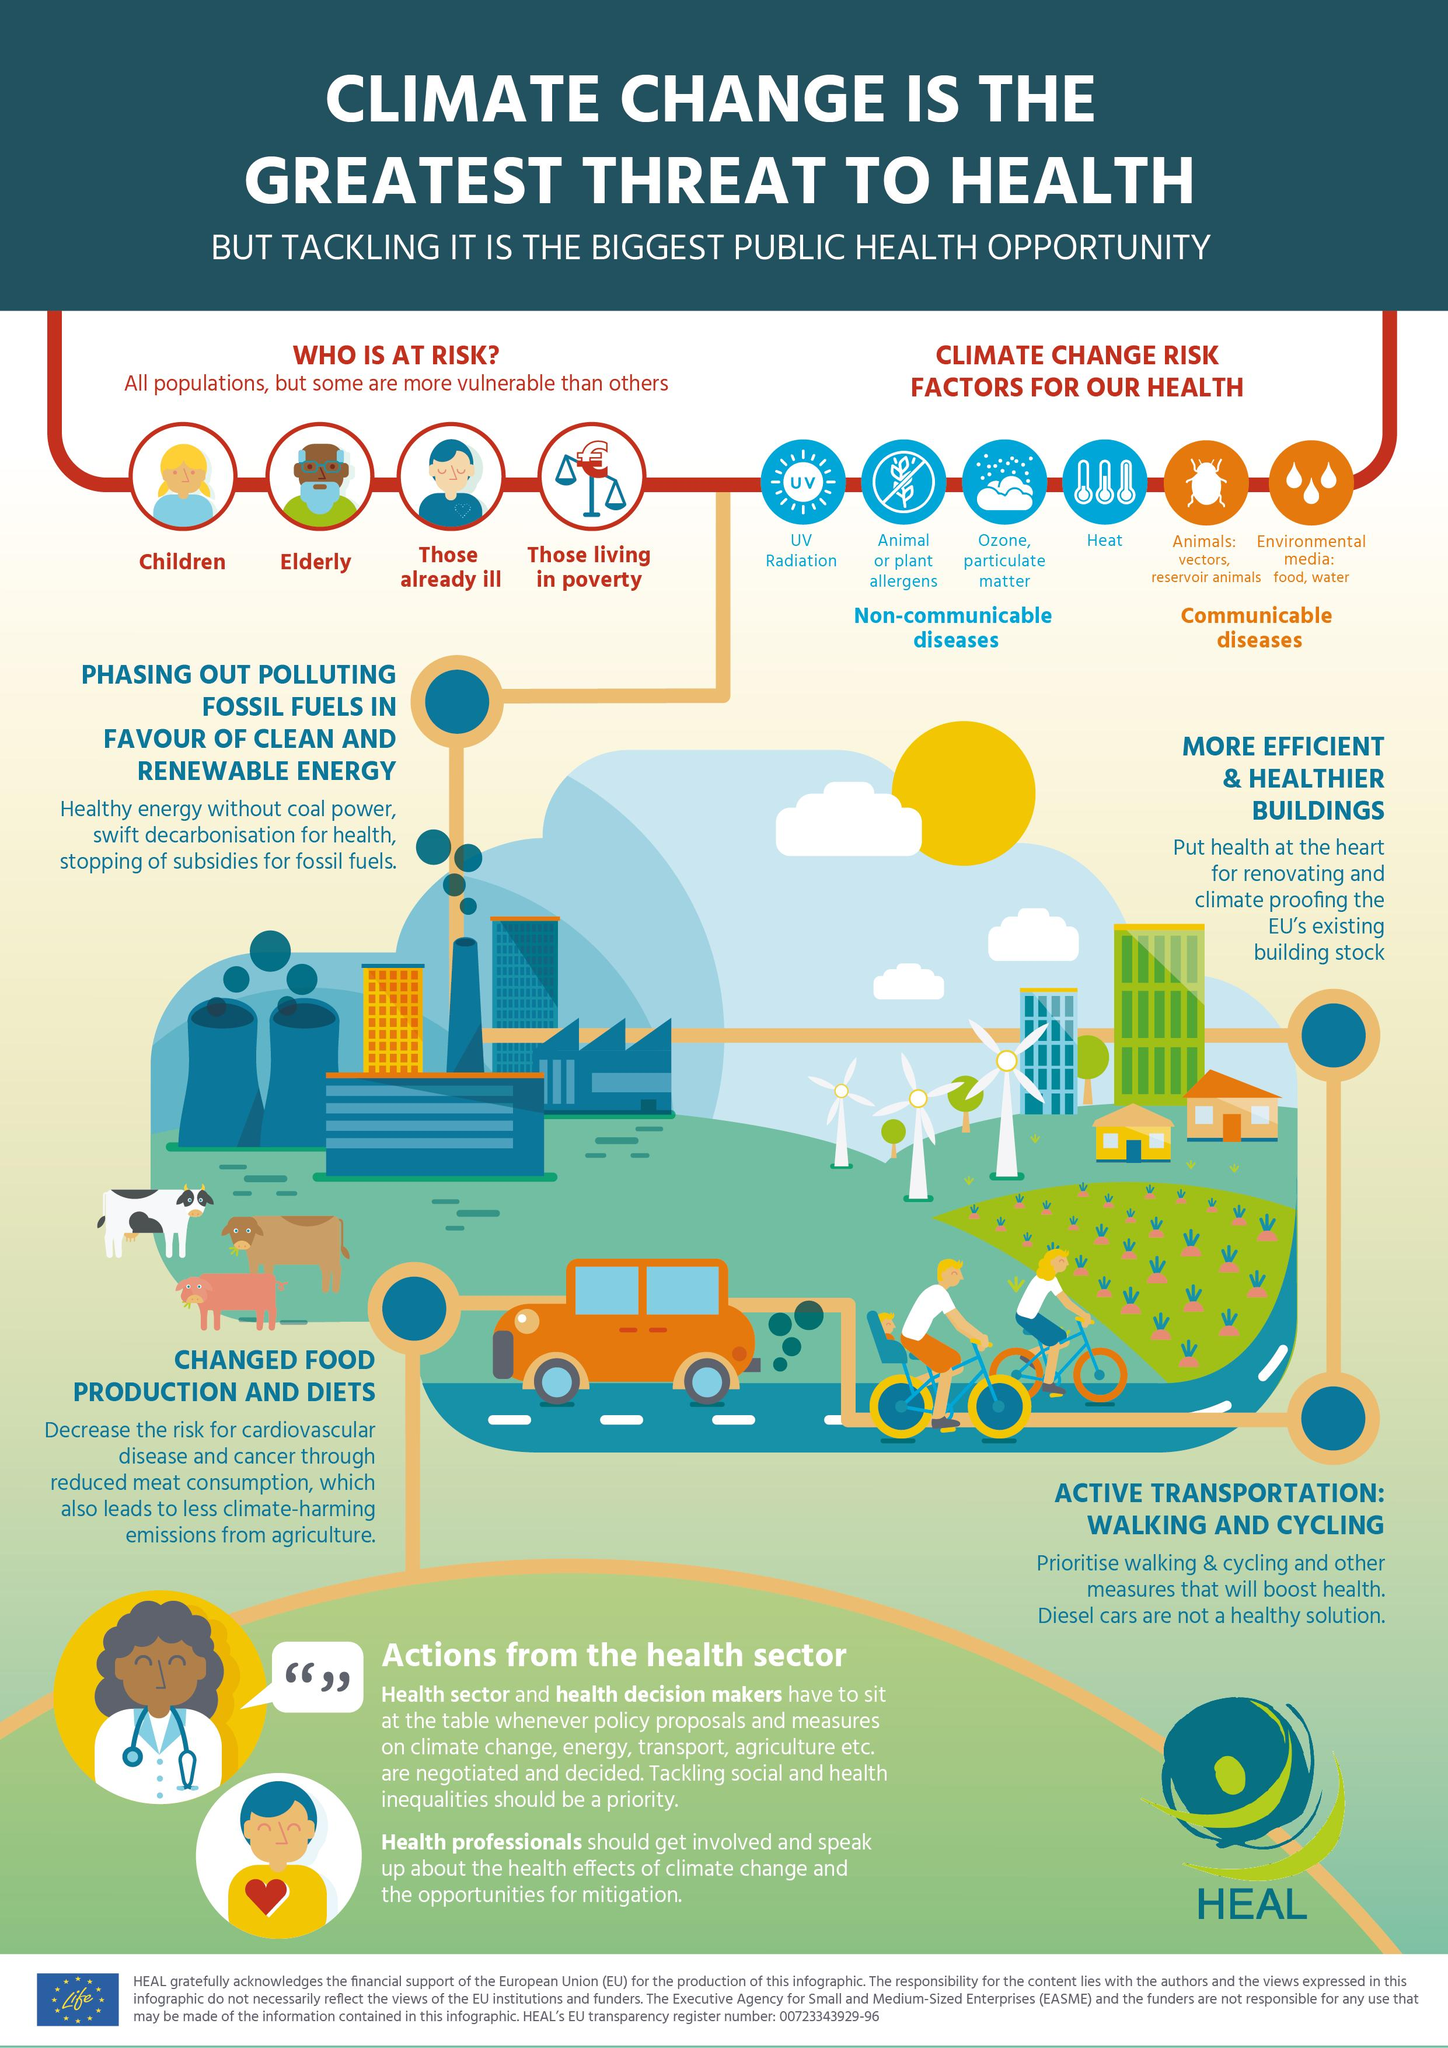Point out several critical features in this image. Climate change poses a significant threat to the health and well-being of already vulnerable populations, including those who are ill. There are 4 non-communicable disease risk factors that have been grouped together. Two communicable diseases are grouped as risk factors. The fourth climate change risk factor mentioned is heat. Elderly people are among those who are at risk due to climate change, and they are mentioned as being at risk in the second group. 